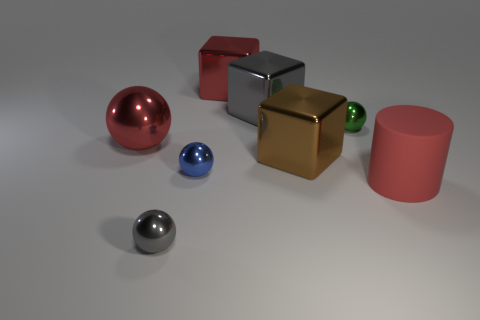Are there any other things that are made of the same material as the cylinder?
Offer a terse response. No. There is a blue thing; are there any tiny blue shiny things behind it?
Your response must be concise. No. Is there a tiny green thing that is left of the big red metallic thing that is to the right of the gray shiny sphere?
Your answer should be compact. No. Are there fewer cubes left of the small blue shiny sphere than big metallic objects that are in front of the red cylinder?
Provide a short and direct response. No. Is there anything else that is the same size as the red block?
Make the answer very short. Yes. The tiny green object has what shape?
Offer a very short reply. Sphere. There is a large red thing behind the green object; what material is it?
Keep it short and to the point. Metal. There is a metallic sphere in front of the red thing in front of the shiny sphere to the left of the small gray object; how big is it?
Your response must be concise. Small. Does the gray cube on the left side of the brown object have the same material as the thing on the left side of the tiny gray metallic ball?
Your response must be concise. Yes. What number of other objects are the same color as the large metal ball?
Provide a short and direct response. 2. 